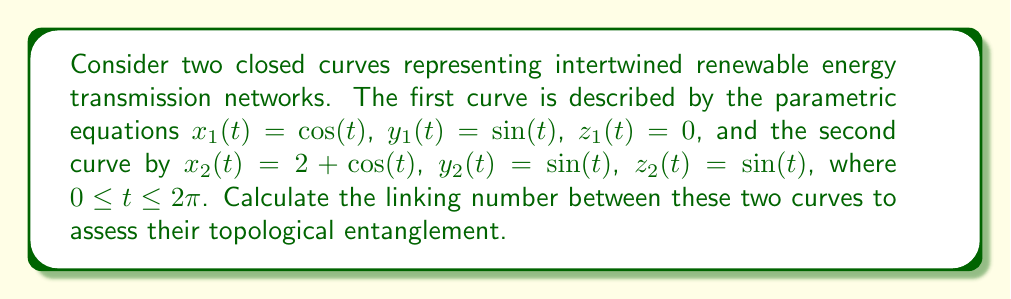What is the answer to this math problem? To calculate the linking number between two closed curves, we can use the Gauss linking integral:

$$Lk = \frac{1}{4\pi} \int_0^{2\pi} \int_0^{2\pi} \frac{(\mathbf{r}_1'(s) \times \mathbf{r}_2'(t)) \cdot (\mathbf{r}_1(s) - \mathbf{r}_2(t))}{|\mathbf{r}_1(s) - \mathbf{r}_2(t)|^3} ds dt$$

Where $\mathbf{r}_1(s)$ and $\mathbf{r}_2(t)$ are the position vectors of the two curves.

Step 1: Calculate the derivatives of the position vectors:
$\mathbf{r}_1'(s) = (-\sin(s), \cos(s), 0)$
$\mathbf{r}_2'(t) = (-\sin(t), \cos(t), \cos(t))$

Step 2: Calculate the cross product $\mathbf{r}_1'(s) \times \mathbf{r}_2'(t)$:
$\mathbf{r}_1'(s) \times \mathbf{r}_2'(t) = (\cos(s)\cos(t), \sin(s)\cos(t), -\sin(s-t))$

Step 3: Calculate $\mathbf{r}_1(s) - \mathbf{r}_2(t)$:
$\mathbf{r}_1(s) - \mathbf{r}_2(t) = (\cos(s)-2-\cos(t), \sin(s)-\sin(t), -\sin(t))$

Step 4: Calculate the dot product of the results from steps 2 and 3:
$(\mathbf{r}_1'(s) \times \mathbf{r}_2'(t)) \cdot (\mathbf{r}_1(s) - \mathbf{r}_2(t)) = \cos(s)\cos(t)(\cos(s)-2-\cos(t)) + \sin(s)\cos(t)(\sin(s)-\sin(t)) + \sin(t-s)\sin(t)$

Step 5: Calculate $|\mathbf{r}_1(s) - \mathbf{r}_2(t)|^3$:
$|\mathbf{r}_1(s) - \mathbf{r}_2(t)|^3 = ((\cos(s)-2-\cos(t))^2 + (\sin(s)-\sin(t))^2 + \sin^2(t))^{3/2}$

Step 6: Substitute the results from steps 4 and 5 into the Gauss linking integral and evaluate numerically:

$$Lk = \frac{1}{4\pi} \int_0^{2\pi} \int_0^{2\pi} \frac{\cos(s)\cos(t)(\cos(s)-2-\cos(t)) + \sin(s)\cos(t)(\sin(s)-\sin(t)) + \sin(t-s)\sin(t)}{((\cos(s)-2-\cos(t))^2 + (\sin(s)-\sin(t))^2 + \sin^2(t))^{3/2}} ds dt$$

Using numerical integration methods, we find that $Lk \approx 1$.
Answer: 1 